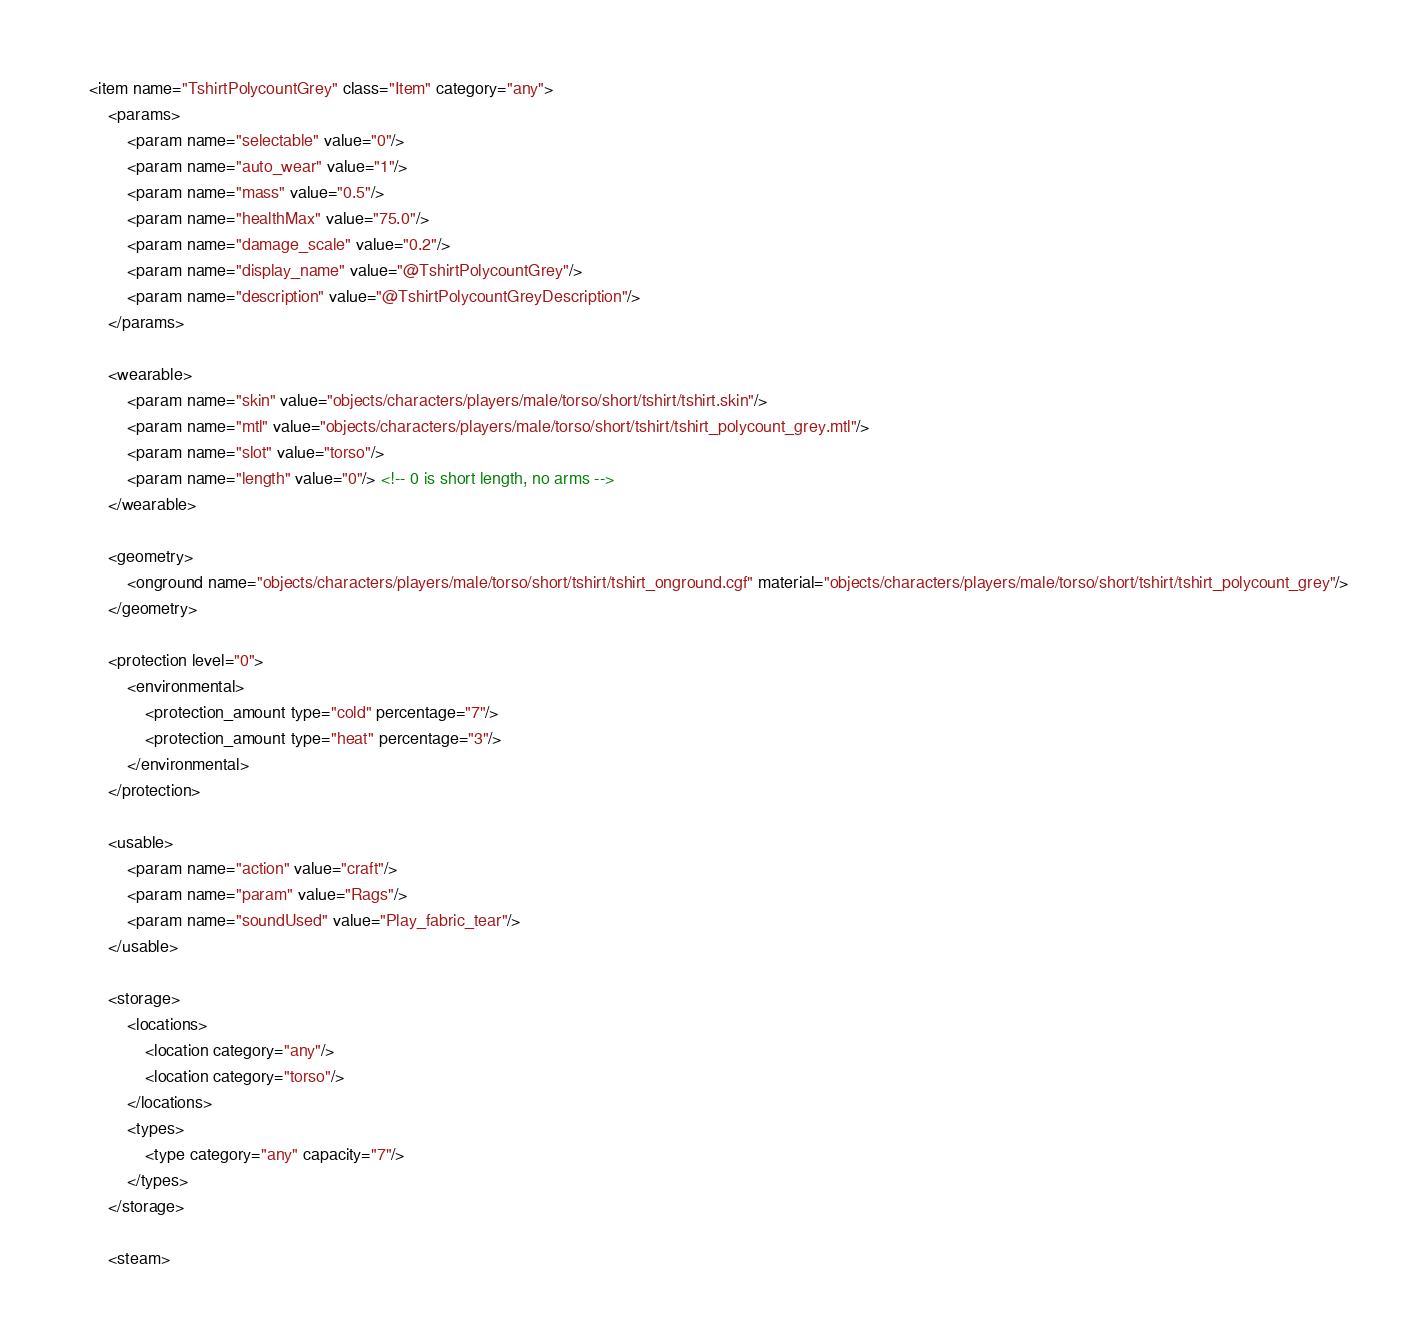Convert code to text. <code><loc_0><loc_0><loc_500><loc_500><_XML_><item name="TshirtPolycountGrey" class="Item" category="any">
	<params>
		<param name="selectable" value="0"/>
		<param name="auto_wear" value="1"/>
		<param name="mass" value="0.5"/>
		<param name="healthMax" value="75.0"/>
		<param name="damage_scale" value="0.2"/>
		<param name="display_name" value="@TshirtPolycountGrey"/>
		<param name="description" value="@TshirtPolycountGreyDescription"/>
	</params>

	<wearable>
		<param name="skin" value="objects/characters/players/male/torso/short/tshirt/tshirt.skin"/>
		<param name="mtl" value="objects/characters/players/male/torso/short/tshirt/tshirt_polycount_grey.mtl"/>
		<param name="slot" value="torso"/>
		<param name="length" value="0"/> <!-- 0 is short length, no arms -->
	</wearable>

	<geometry>
		<onground name="objects/characters/players/male/torso/short/tshirt/tshirt_onground.cgf" material="objects/characters/players/male/torso/short/tshirt/tshirt_polycount_grey"/>
	</geometry>

    <protection level="0">
        <environmental>
            <protection_amount type="cold" percentage="7"/>
            <protection_amount type="heat" percentage="3"/>
        </environmental>
    </protection>

	<usable>
		<param name="action" value="craft"/>
		<param name="param" value="Rags"/>
		<param name="soundUsed" value="Play_fabric_tear"/>
	</usable>

	<storage>
		<locations>
			<location category="any"/>
			<location category="torso"/>
		</locations>
		<types>
			<type category="any" capacity="7"/>
		</types>
	</storage>

	<steam></code> 